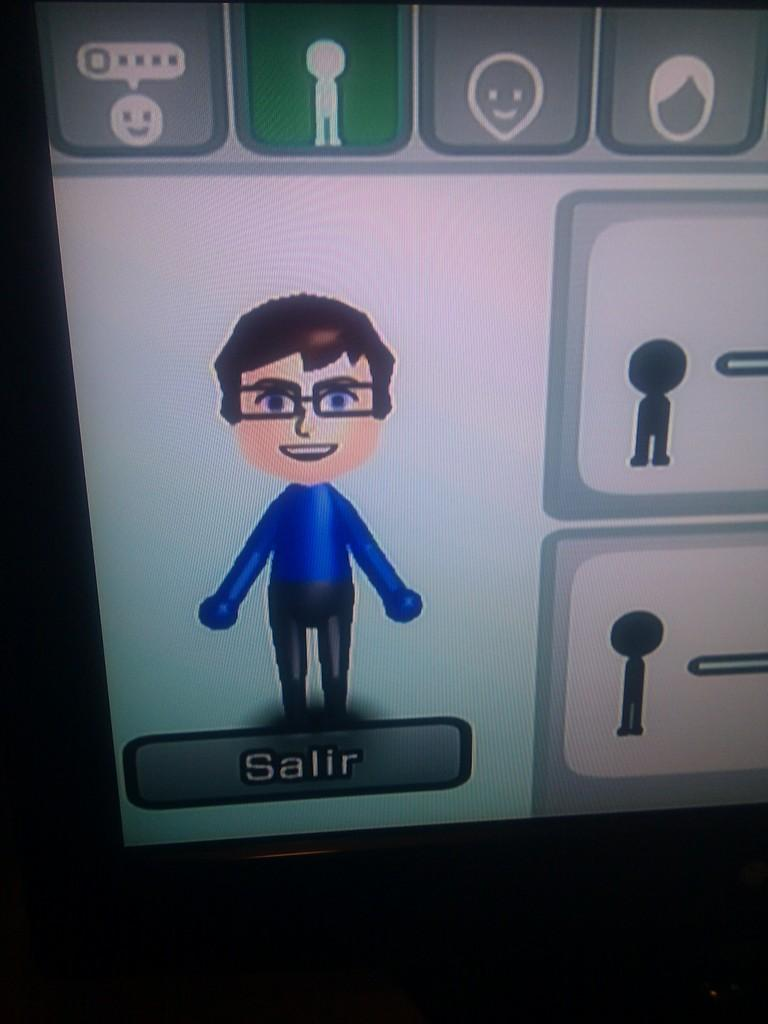What is the main object in the image? There is a screen in the image. What is shown on the screen? The screen depicts a boy. Are there any words or symbols on the screen? Yes, there is a word written on the screen and there are symbols on the screen. What can be seen in the background of the image? There is a dark side in the image. How many accounts does the boy have on the screen? There is no mention of accounts in the image; the screen only depicts a boy and has a word and symbols on it. Is there any eggnog being served in the image? There is no eggnog present in the image. 